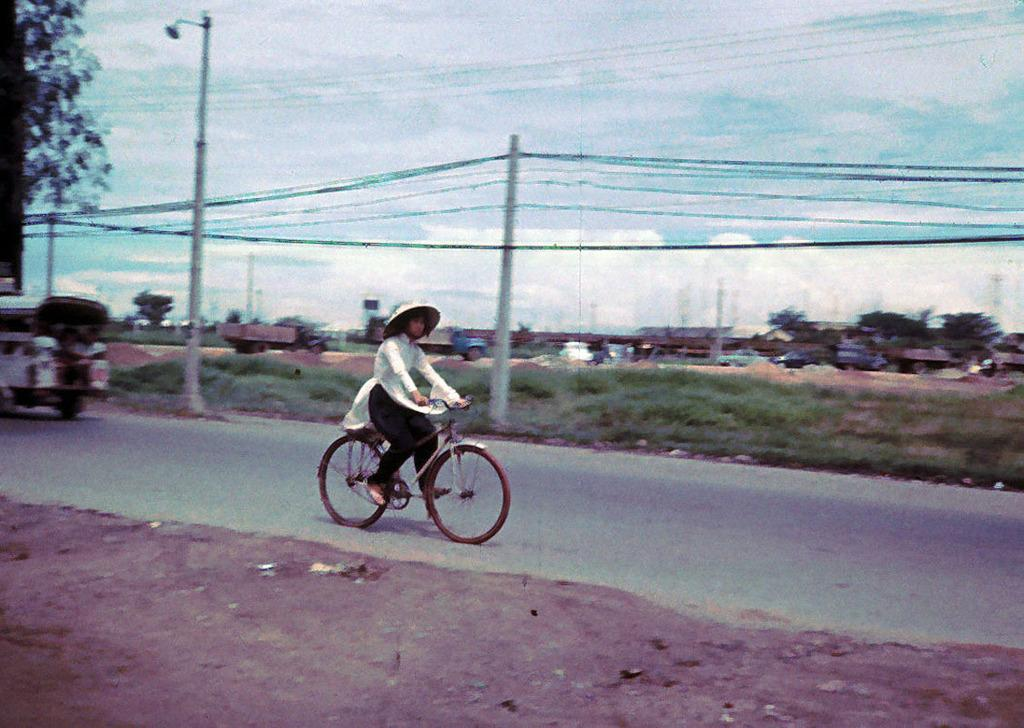What is the person in the image doing? The person is riding a bicycle in the image. Where is the person riding the bicycle? The person is on the road. What can be seen in the background of the image? There are vehicles, poles and cables, and trees visible in the background of the image. What type of yarn is being used to create the middle of the bicycle in the image? There is no yarn present in the image, and the bicycle does not have a middle made of yarn. 